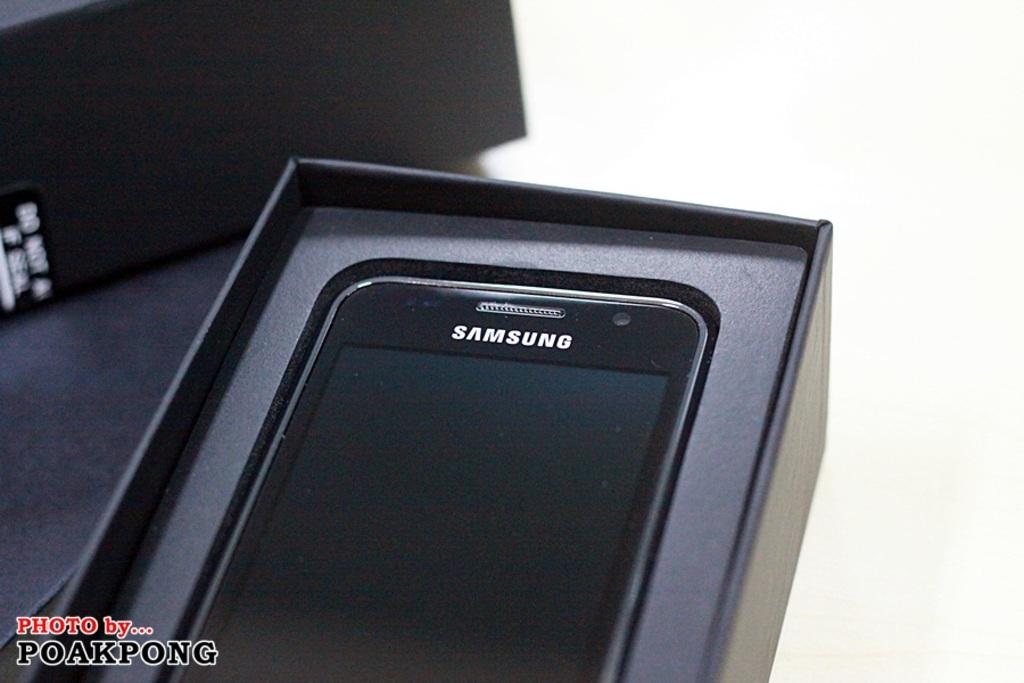What is the brand of this phone?
Provide a succinct answer. Samsung. 